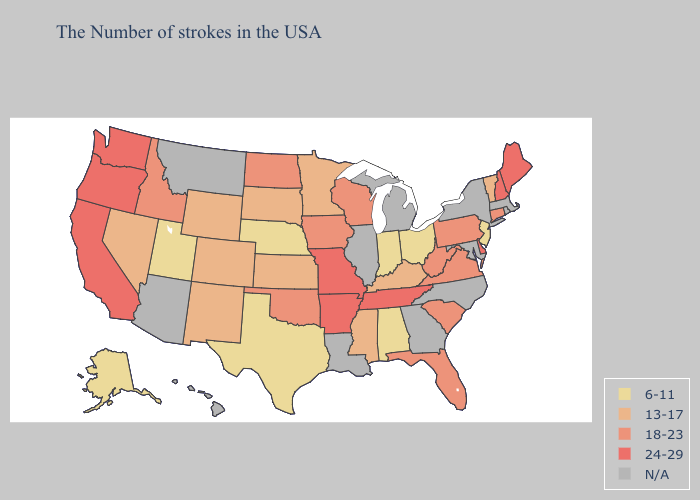Name the states that have a value in the range 6-11?
Concise answer only. New Jersey, Ohio, Indiana, Alabama, Nebraska, Texas, Utah, Alaska. Does Pennsylvania have the lowest value in the Northeast?
Give a very brief answer. No. What is the highest value in states that border New Mexico?
Give a very brief answer. 18-23. Which states hav the highest value in the South?
Concise answer only. Delaware, Tennessee, Arkansas. Name the states that have a value in the range 18-23?
Answer briefly. Connecticut, Pennsylvania, Virginia, South Carolina, West Virginia, Florida, Wisconsin, Iowa, Oklahoma, North Dakota, Idaho. What is the value of Illinois?
Concise answer only. N/A. What is the lowest value in the USA?
Be succinct. 6-11. Does the first symbol in the legend represent the smallest category?
Concise answer only. Yes. Among the states that border Minnesota , which have the highest value?
Write a very short answer. Wisconsin, Iowa, North Dakota. Name the states that have a value in the range 13-17?
Answer briefly. Vermont, Kentucky, Mississippi, Minnesota, Kansas, South Dakota, Wyoming, Colorado, New Mexico, Nevada. Name the states that have a value in the range N/A?
Concise answer only. Massachusetts, Rhode Island, New York, Maryland, North Carolina, Georgia, Michigan, Illinois, Louisiana, Montana, Arizona, Hawaii. Name the states that have a value in the range N/A?
Keep it brief. Massachusetts, Rhode Island, New York, Maryland, North Carolina, Georgia, Michigan, Illinois, Louisiana, Montana, Arizona, Hawaii. Does Tennessee have the highest value in the South?
Keep it brief. Yes. What is the value of Mississippi?
Give a very brief answer. 13-17. 